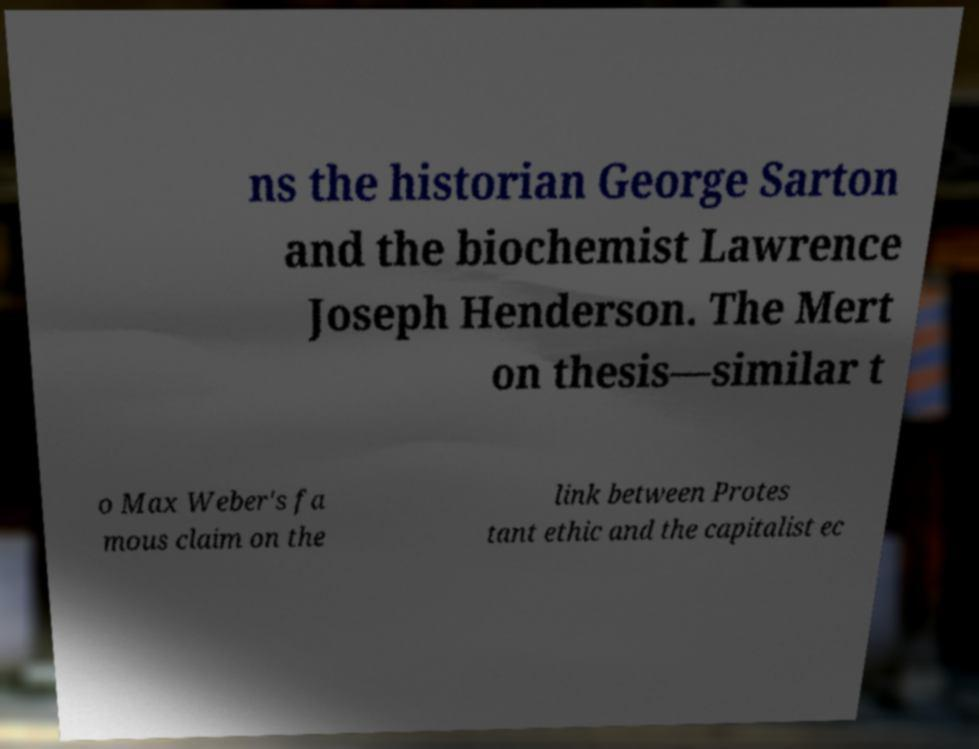What messages or text are displayed in this image? I need them in a readable, typed format. ns the historian George Sarton and the biochemist Lawrence Joseph Henderson. The Mert on thesis—similar t o Max Weber's fa mous claim on the link between Protes tant ethic and the capitalist ec 